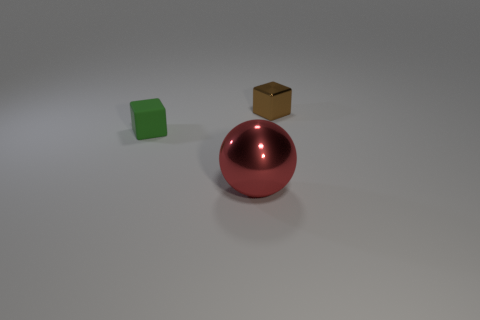Add 1 spheres. How many objects exist? 4 Subtract all cubes. How many objects are left? 1 Subtract all large things. Subtract all small metal things. How many objects are left? 1 Add 2 green matte blocks. How many green matte blocks are left? 3 Add 2 small shiny cylinders. How many small shiny cylinders exist? 2 Subtract 0 gray spheres. How many objects are left? 3 